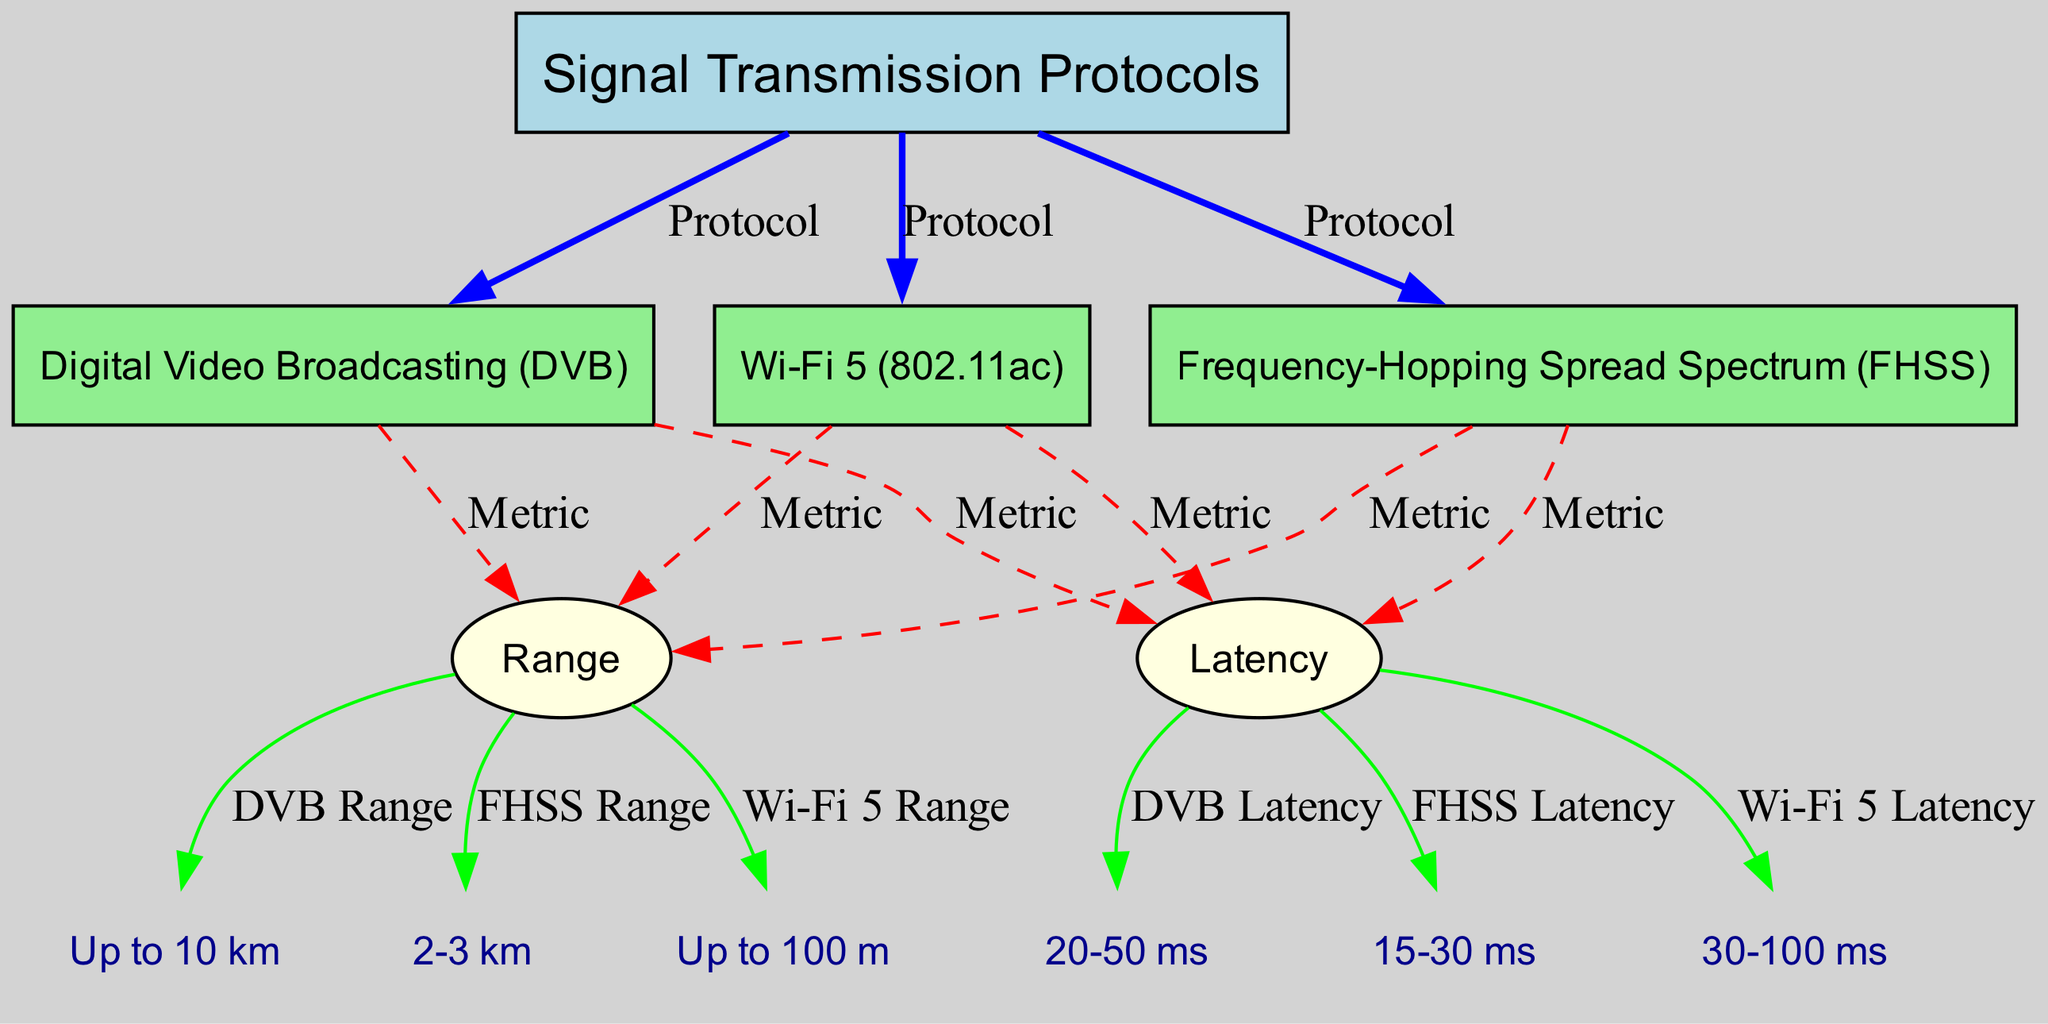What are the three signal transmission protocols shown? The diagram directly lists three protocols: Digital Video Broadcasting (DVB), Frequency-Hopping Spread Spectrum (FHSS), and Wi-Fi 5 (802.11ac). These protocols are laid out under the main node labelled "Signal Transmission Protocols."
Answer: Digital Video Broadcasting, Frequency-Hopping Spread Spectrum, Wi-Fi 5 Which protocol has the lowest latency? By examining the latency values attributed to each protocol, DVB shows a latency range of 20-50 ms, FHSS has 15-30 ms, and Wi-Fi 5 has 30-100 ms. The lowest value among these is from FHSS (15-30 ms).
Answer: 15-30 ms What is the range of Wi-Fi 5? The diagram states that the range of Wi-Fi 5 is listed directly under the Wi-Fi 5 protocol. It shows a range of up to 100 m.
Answer: Up to 100 m Which protocol provides the longest range? By analyzing the ranges provided, DVB offers up to 10 km, FHSS offers 2-3 km, and Wi-Fi 5 offers up to 100 m. The longest range is thus indicated by DVB, which is up to 10 km.
Answer: Up to 10 km What is the range difference between DVB and FHSS? The range for DVB is up to 10 km, and for FHSS, it is 2-3 km. The difference can be calculated by recognizing that 10 km (DVB) is significantly larger than 3 km (the upper end of FHSS). Thus, the difference is 10 km - 3 km = 7 km.
Answer: 7 km 